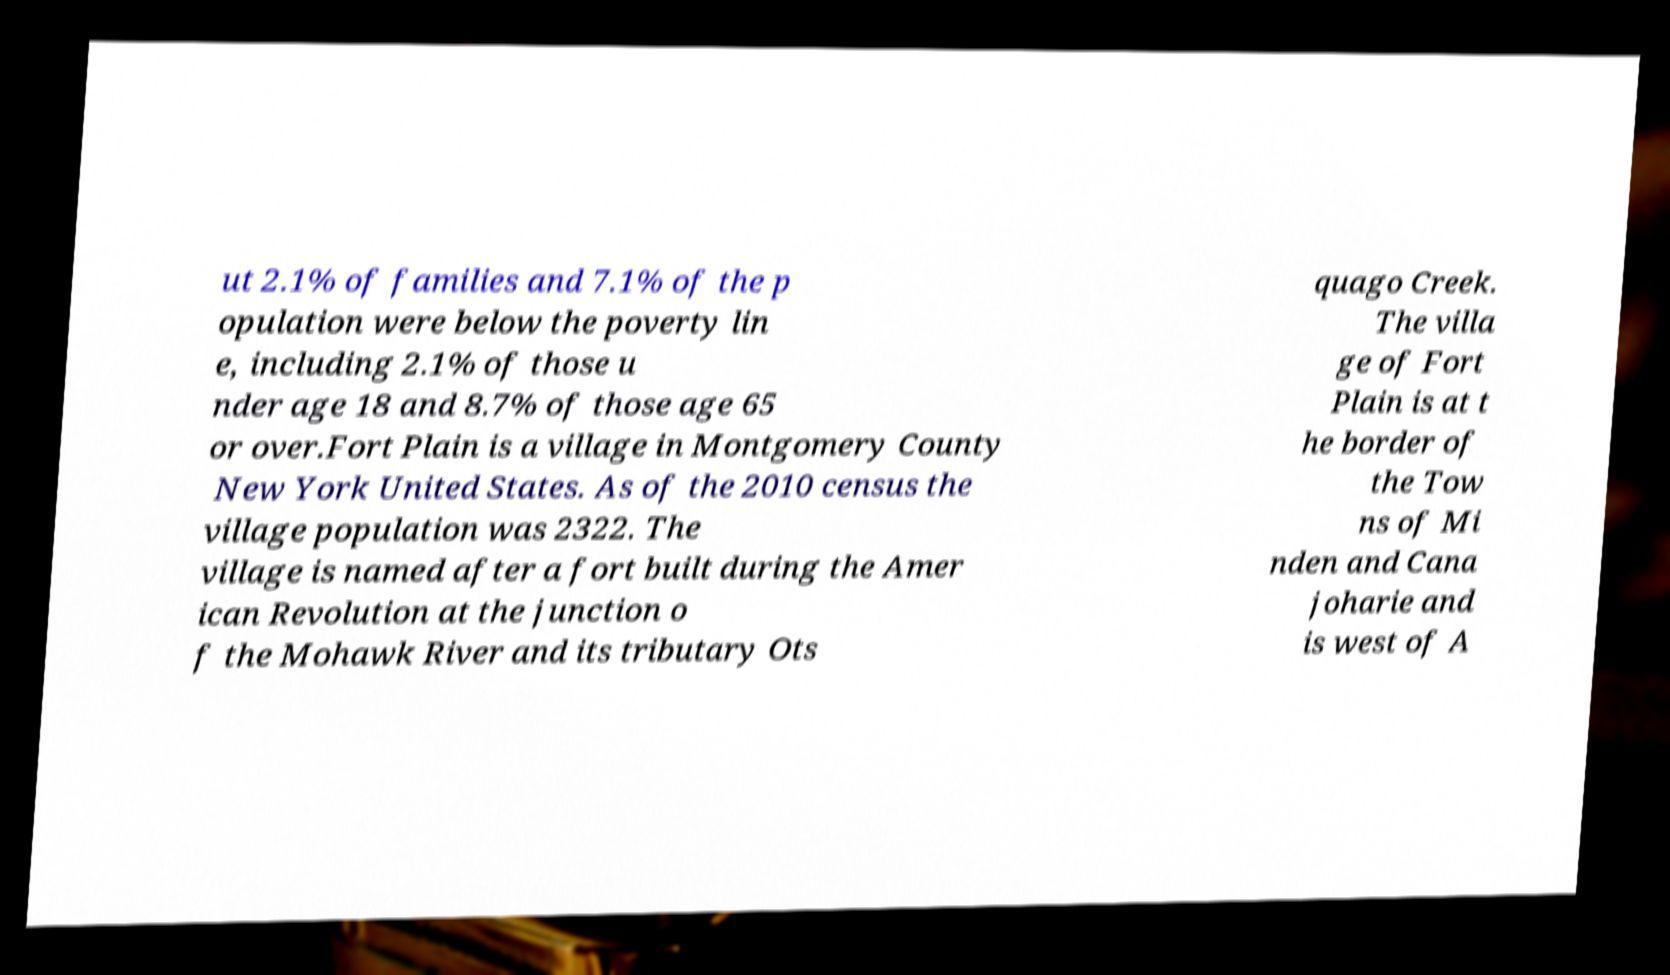Can you read and provide the text displayed in the image?This photo seems to have some interesting text. Can you extract and type it out for me? ut 2.1% of families and 7.1% of the p opulation were below the poverty lin e, including 2.1% of those u nder age 18 and 8.7% of those age 65 or over.Fort Plain is a village in Montgomery County New York United States. As of the 2010 census the village population was 2322. The village is named after a fort built during the Amer ican Revolution at the junction o f the Mohawk River and its tributary Ots quago Creek. The villa ge of Fort Plain is at t he border of the Tow ns of Mi nden and Cana joharie and is west of A 